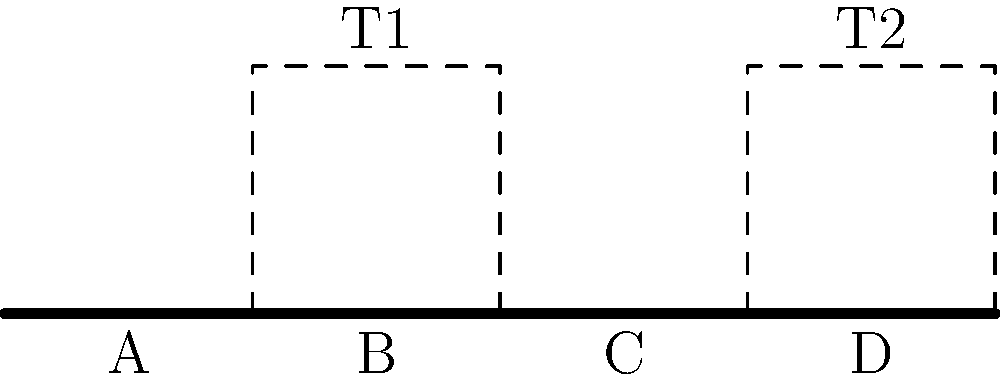In the topological space representing a film's scene continuity, scenes A, B, C, and D are connected linearly, with two transition spaces T1 and T2. If we remove scene C, which of the following statements is true about the resulting space? To answer this question, let's analyze the topological space step-by-step:

1. Initially, we have four scenes (A, B, C, D) connected linearly.
2. There are two transition spaces: T1 connecting B and C, and T2 connecting C and D.
3. When we remove scene C:
   a. The direct connection between B and D is lost.
   b. T1 now connects B to the space where C was.
   c. T2 now connects the space where C was to D.
4. Topologically, this creates a new continuous space:
   A -- B -- T1 -- T2 -- D
5. The removal of C doesn't disconnect the space entirely.
6. However, it does create a "detour" through the transition spaces.
7. This new configuration maintains continuity but alters the path between B and D.

In topological terms, removing C creates a homotopy equivalent space to the original, preserving connectivity but changing the specific path between scenes.
Answer: The space remains connected but with an altered path between B and D through T1 and T2. 